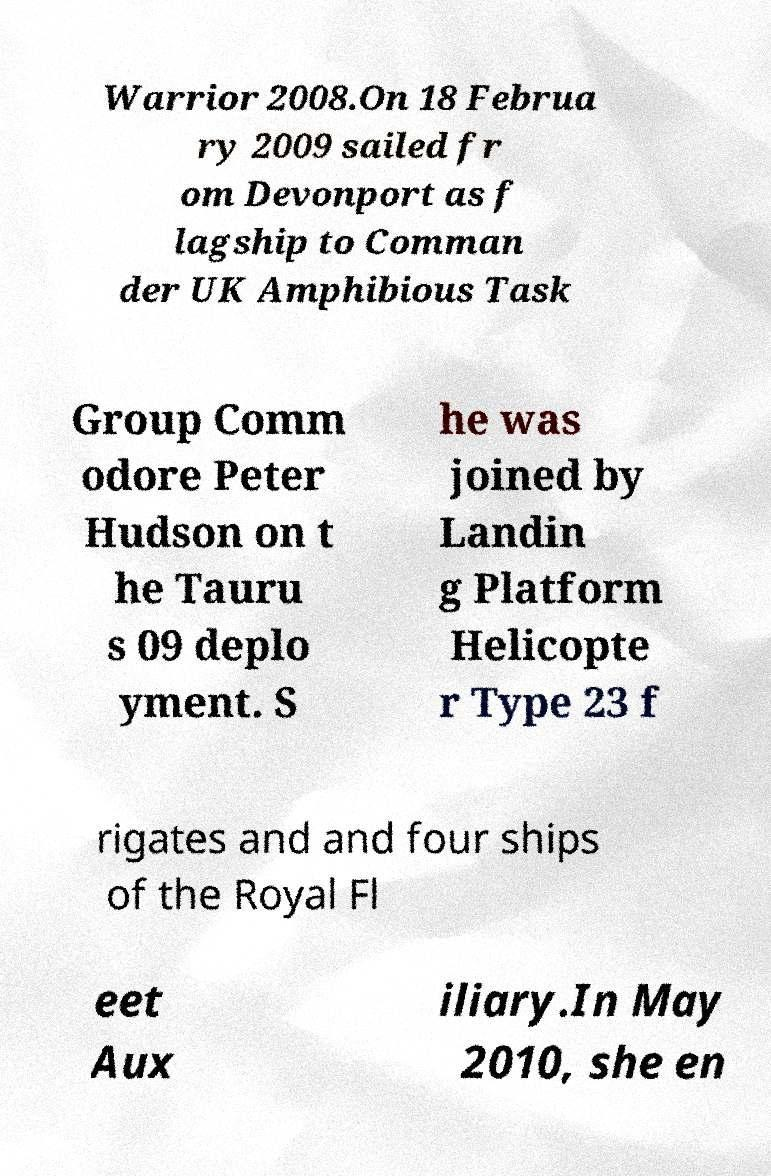Can you read and provide the text displayed in the image?This photo seems to have some interesting text. Can you extract and type it out for me? Warrior 2008.On 18 Februa ry 2009 sailed fr om Devonport as f lagship to Comman der UK Amphibious Task Group Comm odore Peter Hudson on t he Tauru s 09 deplo yment. S he was joined by Landin g Platform Helicopte r Type 23 f rigates and and four ships of the Royal Fl eet Aux iliary.In May 2010, she en 